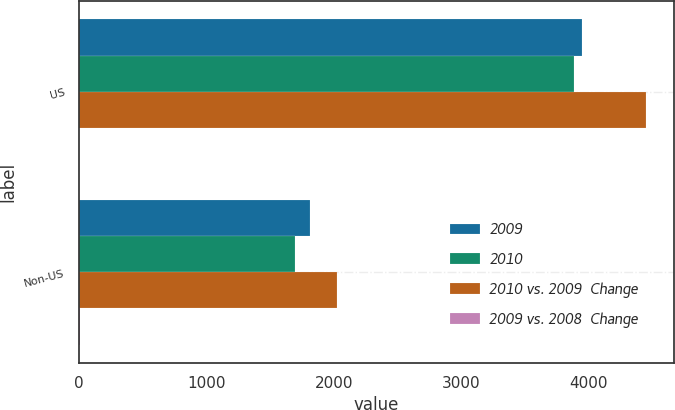Convert chart. <chart><loc_0><loc_0><loc_500><loc_500><stacked_bar_chart><ecel><fcel>US<fcel>Non-US<nl><fcel>2009<fcel>3949.9<fcel>1809.3<nl><fcel>2010<fcel>3881.4<fcel>1696.2<nl><fcel>2010 vs. 2009  Change<fcel>4447.2<fcel>2023.4<nl><fcel>2009 vs. 2008  Change<fcel>1.8<fcel>6.7<nl></chart> 